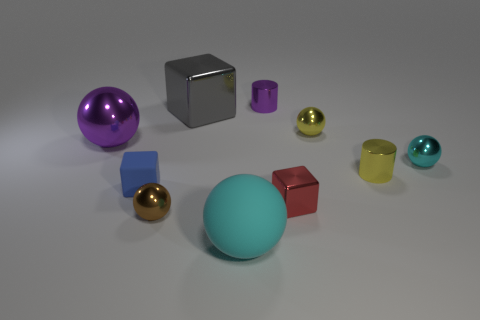Are there more tiny rubber cubes that are left of the tiny red metallic object than big blue balls?
Give a very brief answer. Yes. Is there anything else that is the same color as the large metallic sphere?
Offer a terse response. Yes. The small cyan object that is made of the same material as the brown ball is what shape?
Offer a very short reply. Sphere. Is the cyan ball that is right of the large cyan matte ball made of the same material as the red block?
Your answer should be compact. Yes. What is the shape of the tiny object that is the same color as the large shiny sphere?
Keep it short and to the point. Cylinder. Does the cylinder left of the yellow cylinder have the same color as the large ball to the left of the brown shiny thing?
Ensure brevity in your answer.  Yes. What number of shiny spheres are left of the large metal block and on the right side of the tiny yellow ball?
Give a very brief answer. 0. What is the tiny blue block made of?
Keep it short and to the point. Rubber. What is the shape of the yellow object that is the same size as the yellow sphere?
Your response must be concise. Cylinder. Do the small sphere left of the small red shiny cube and the cyan sphere that is left of the small red metallic object have the same material?
Your answer should be very brief. No. 